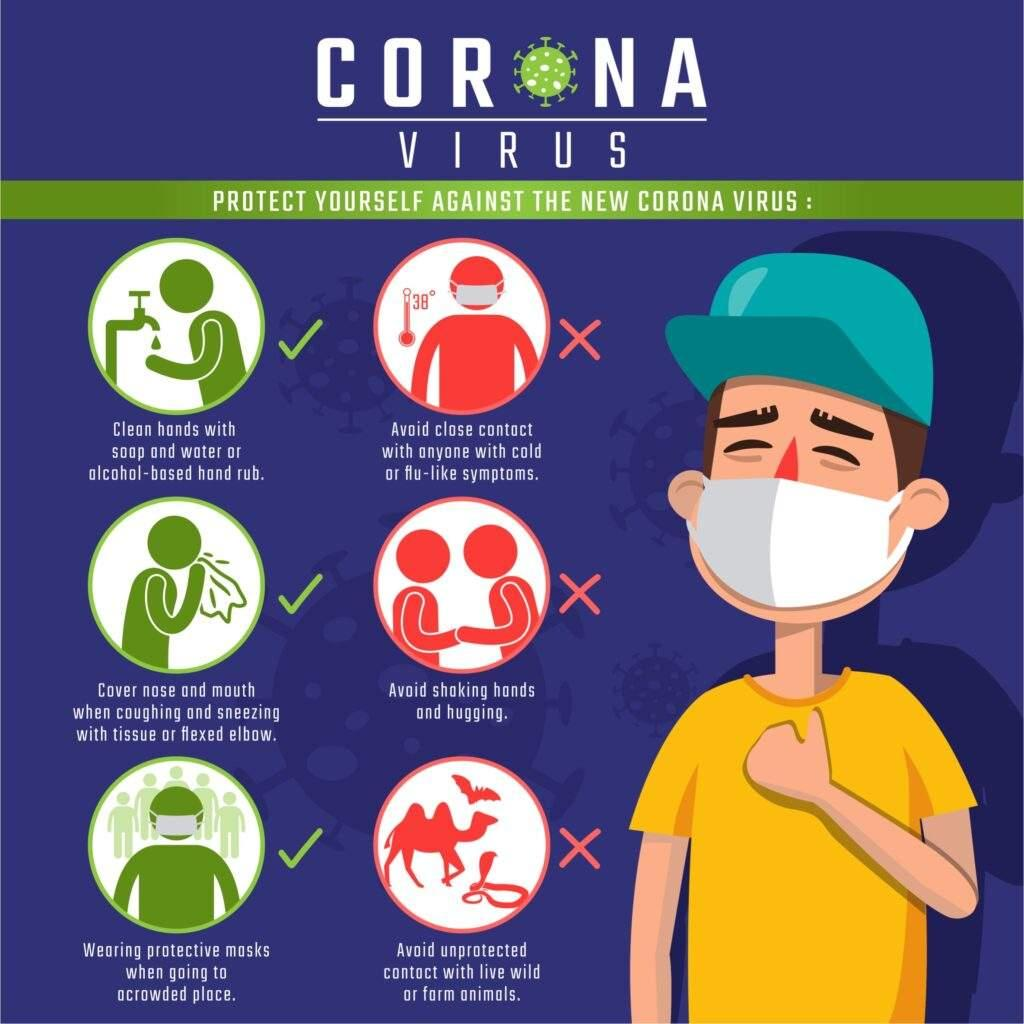Highlight a few significant elements in this photo. The infographic image contains three examples of "don'ts. The infographic image contains three do's. 